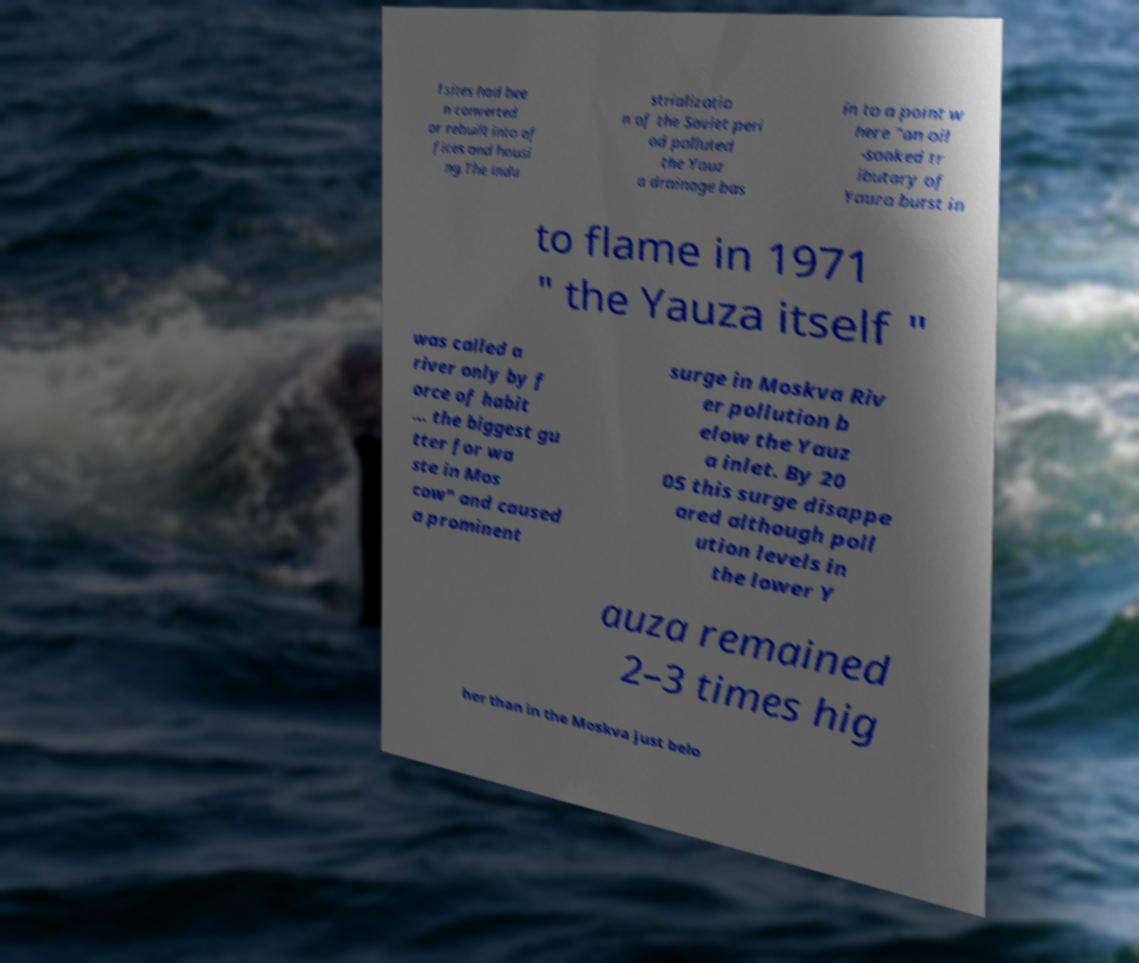Could you assist in decoding the text presented in this image and type it out clearly? l sites had bee n converted or rebuilt into of fices and housi ng.The indu strializatio n of the Soviet peri od polluted the Yauz a drainage bas in to a point w here "an oil -soaked tr ibutary of Yauza burst in to flame in 1971 " the Yauza itself " was called a river only by f orce of habit ... the biggest gu tter for wa ste in Mos cow" and caused a prominent surge in Moskva Riv er pollution b elow the Yauz a inlet. By 20 05 this surge disappe ared although poll ution levels in the lower Y auza remained 2–3 times hig her than in the Moskva just belo 